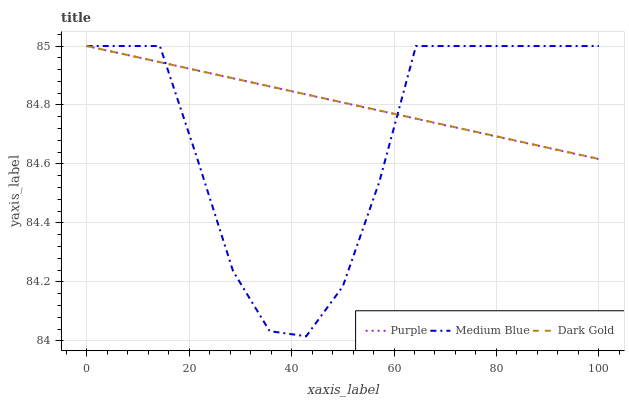Does Dark Gold have the minimum area under the curve?
Answer yes or no. No. Does Medium Blue have the maximum area under the curve?
Answer yes or no. No. Is Dark Gold the smoothest?
Answer yes or no. No. Is Dark Gold the roughest?
Answer yes or no. No. Does Dark Gold have the lowest value?
Answer yes or no. No. 